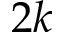Convert formula to latex. <formula><loc_0><loc_0><loc_500><loc_500>2 k</formula> 